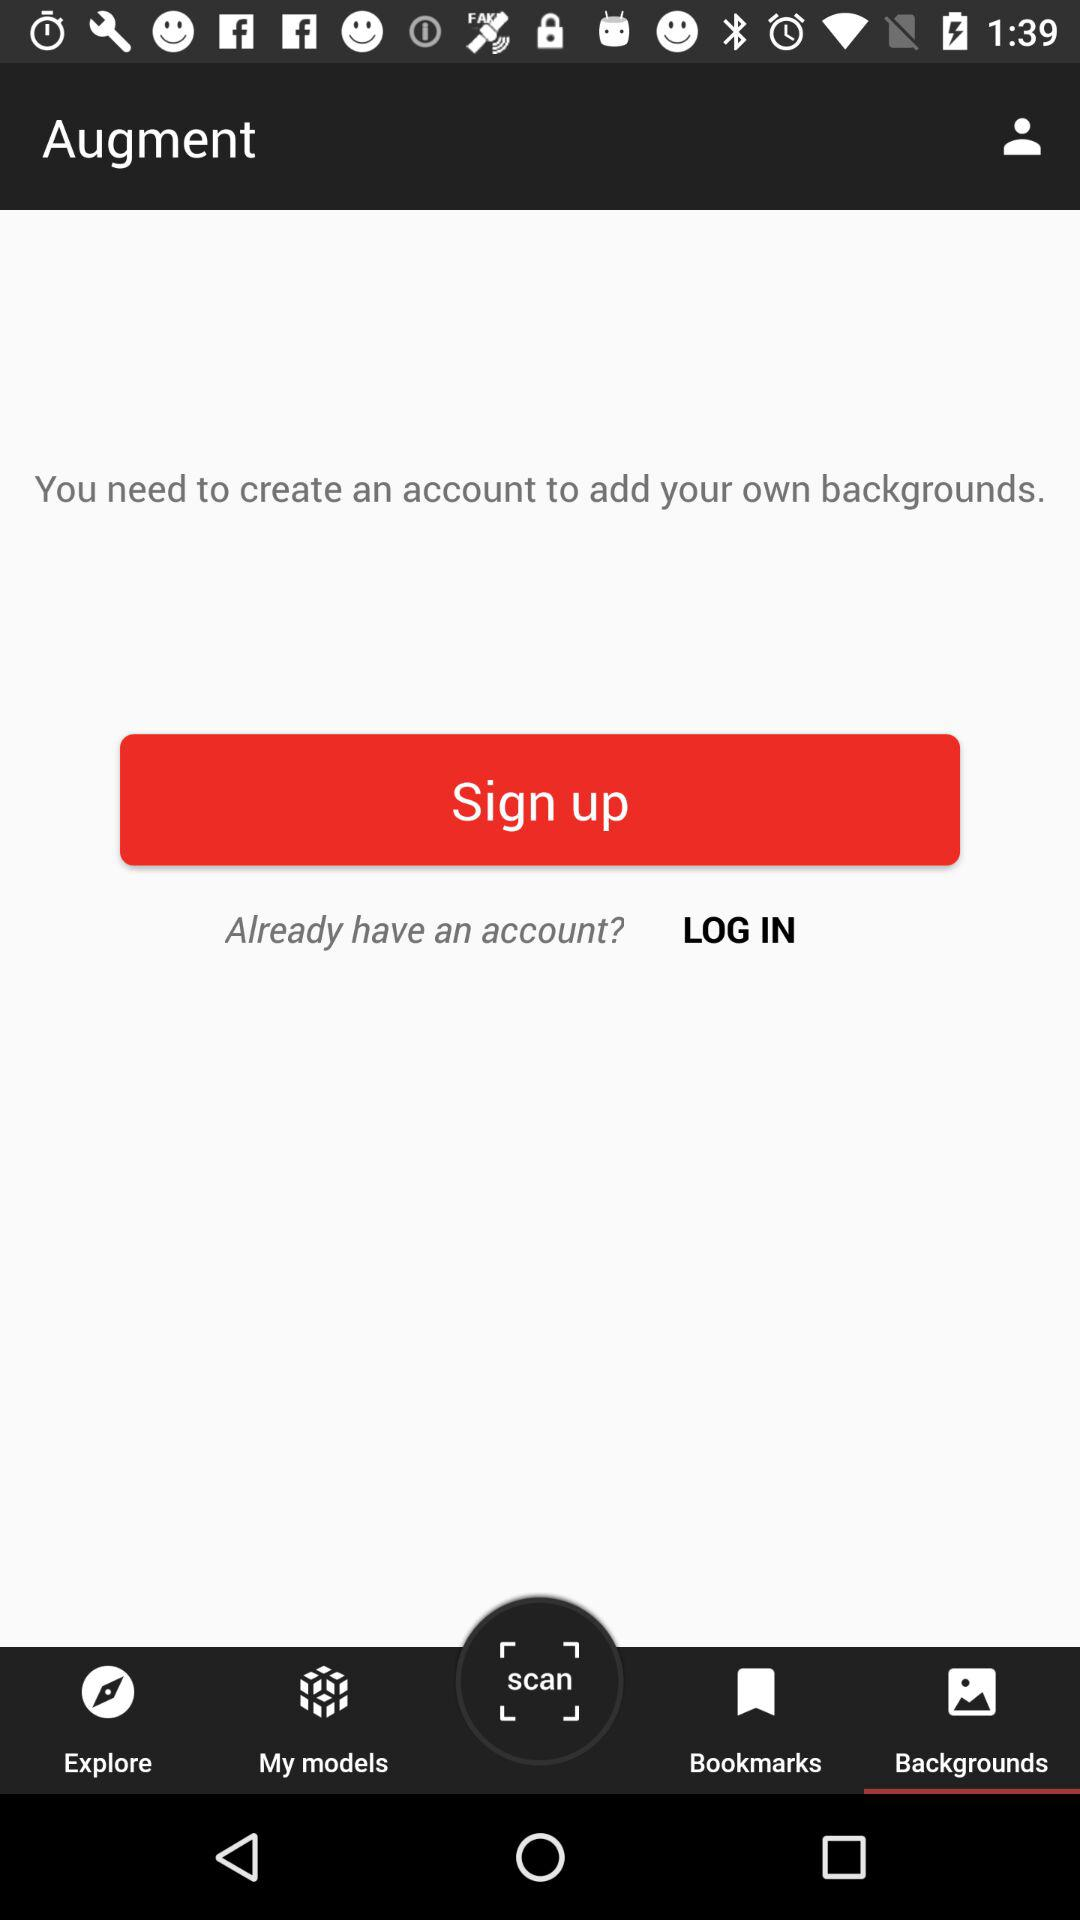Which is the selected tab? The selected tab is "Backgrounds". 